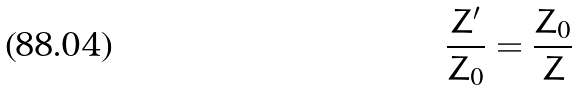<formula> <loc_0><loc_0><loc_500><loc_500>\frac { Z ^ { \prime } } { Z _ { 0 } } = \frac { Z _ { 0 } } { Z }</formula> 